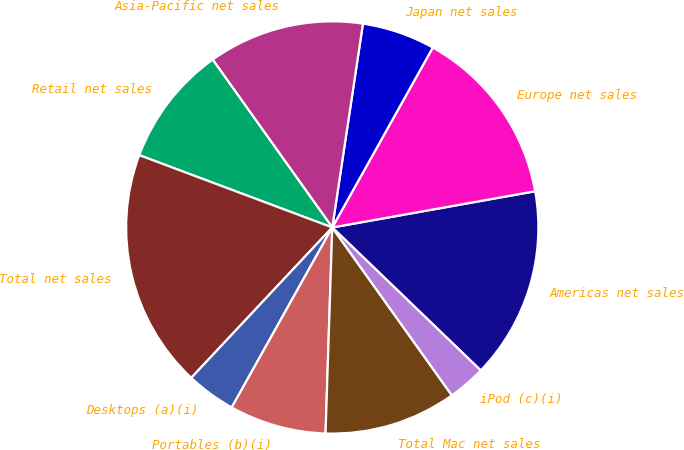Convert chart. <chart><loc_0><loc_0><loc_500><loc_500><pie_chart><fcel>Americas net sales<fcel>Europe net sales<fcel>Japan net sales<fcel>Asia-Pacific net sales<fcel>Retail net sales<fcel>Total net sales<fcel>Desktops (a)(i)<fcel>Portables (b)(i)<fcel>Total Mac net sales<fcel>iPod (c)(i)<nl><fcel>15.01%<fcel>14.08%<fcel>5.73%<fcel>12.23%<fcel>9.44%<fcel>18.72%<fcel>3.88%<fcel>7.59%<fcel>10.37%<fcel>2.95%<nl></chart> 